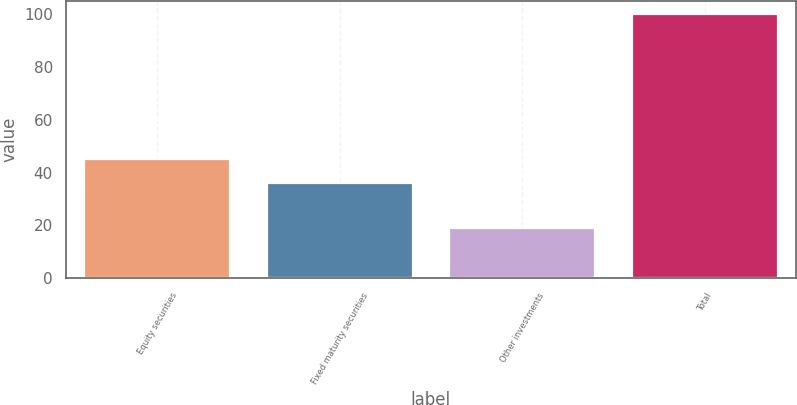Convert chart. <chart><loc_0><loc_0><loc_500><loc_500><bar_chart><fcel>Equity securities<fcel>Fixed maturity securities<fcel>Other investments<fcel>Total<nl><fcel>45<fcel>36<fcel>19<fcel>100<nl></chart> 